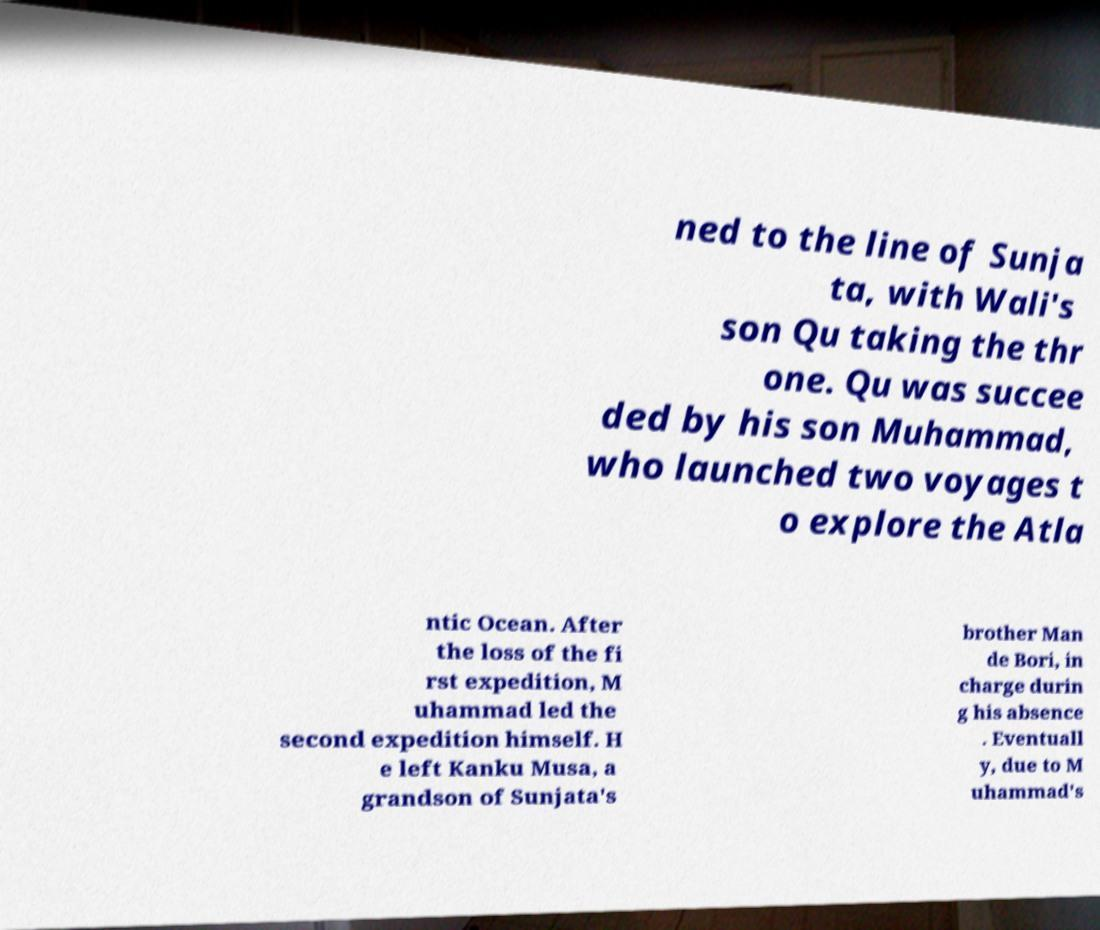Can you read and provide the text displayed in the image?This photo seems to have some interesting text. Can you extract and type it out for me? ned to the line of Sunja ta, with Wali's son Qu taking the thr one. Qu was succee ded by his son Muhammad, who launched two voyages t o explore the Atla ntic Ocean. After the loss of the fi rst expedition, M uhammad led the second expedition himself. H e left Kanku Musa, a grandson of Sunjata's brother Man de Bori, in charge durin g his absence . Eventuall y, due to M uhammad's 